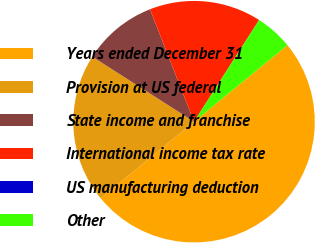<chart> <loc_0><loc_0><loc_500><loc_500><pie_chart><fcel>Years ended December 31<fcel>Provision at US federal<fcel>State income and franchise<fcel>International income tax rate<fcel>US manufacturing deduction<fcel>Other<nl><fcel>49.99%<fcel>20.0%<fcel>10.0%<fcel>15.0%<fcel>0.01%<fcel>5.01%<nl></chart> 